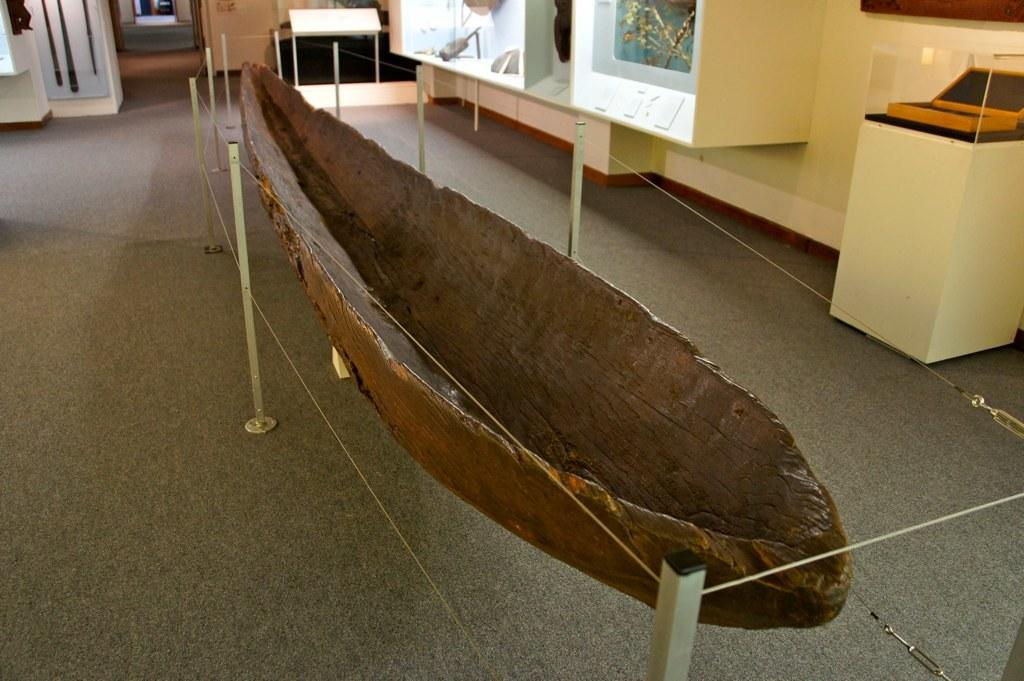What is the main subject of the image? The main subject of the image is a boat. Can you describe the boat's surroundings? There are poles and wires around the boat. What else can be seen in the background of the image? There are other unspecified elements in the background of the image. What type of stamp is on the boat's hull in the image? There is no stamp visible on the boat's hull in the image. What month is depicted in the image? The image does not depict a specific month; it only shows a boat with poles and wires around it. 